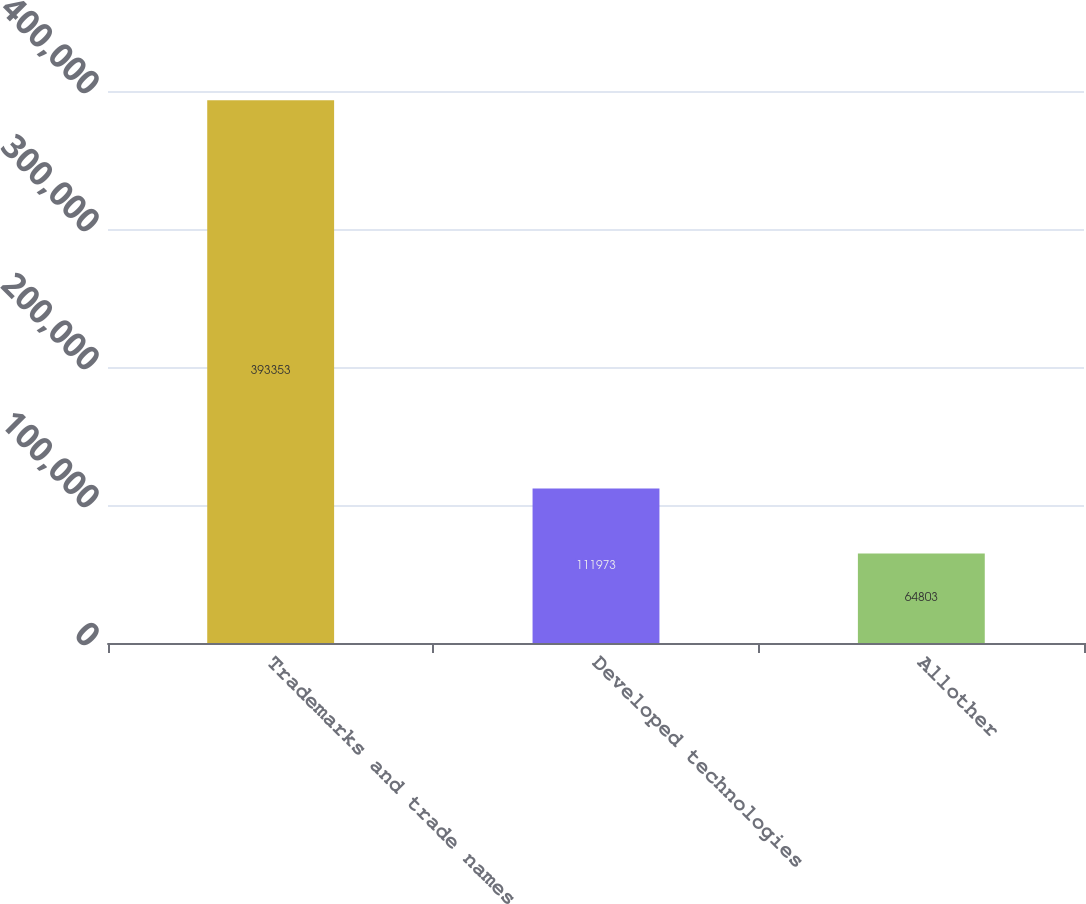Convert chart. <chart><loc_0><loc_0><loc_500><loc_500><bar_chart><fcel>Trademarks and trade names<fcel>Developed technologies<fcel>Allother<nl><fcel>393353<fcel>111973<fcel>64803<nl></chart> 